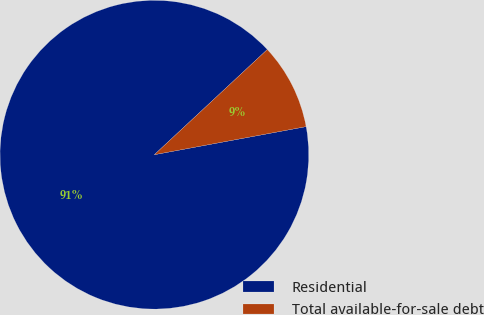<chart> <loc_0><loc_0><loc_500><loc_500><pie_chart><fcel>Residential<fcel>Total available-for-sale debt<nl><fcel>90.98%<fcel>9.02%<nl></chart> 